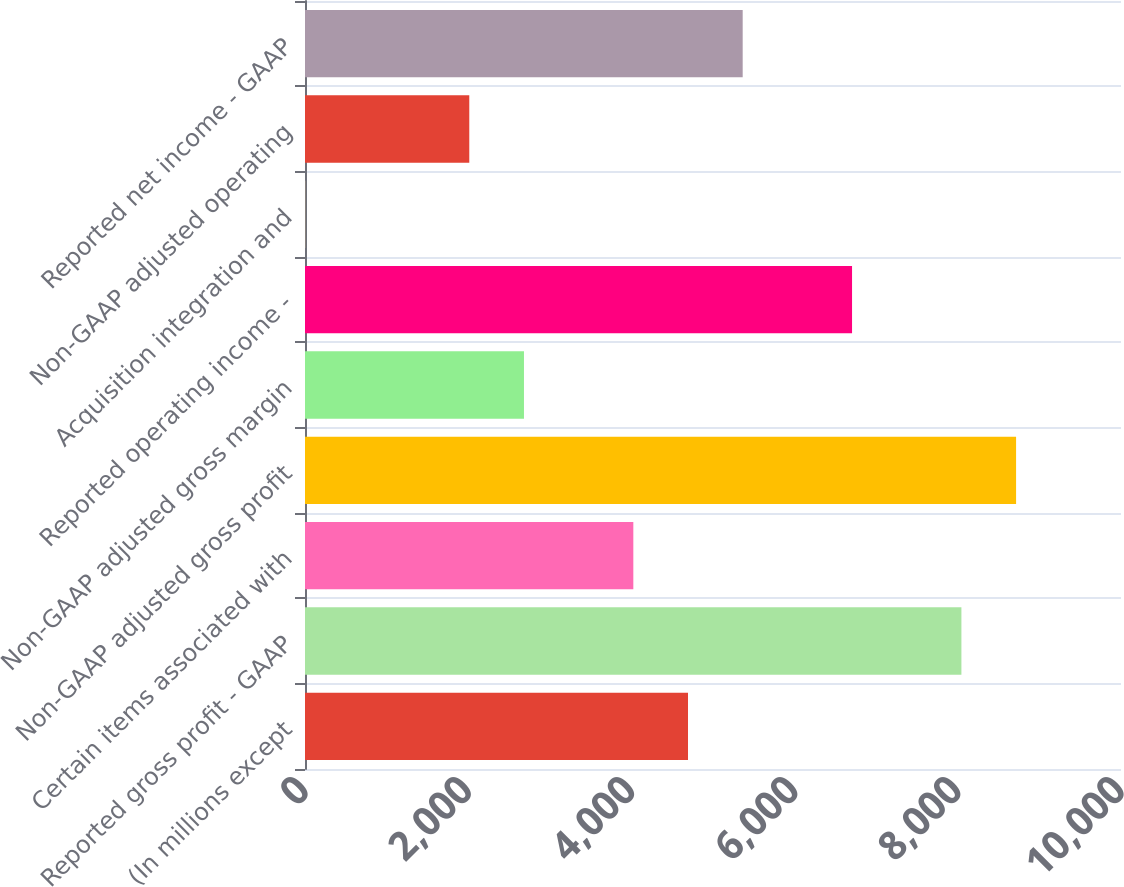<chart> <loc_0><loc_0><loc_500><loc_500><bar_chart><fcel>(In millions except<fcel>Reported gross profit - GAAP<fcel>Certain items associated with<fcel>Non-GAAP adjusted gross profit<fcel>Non-GAAP adjusted gross margin<fcel>Reported operating income -<fcel>Acquisition integration and<fcel>Non-GAAP adjusted operating<fcel>Reported net income - GAAP<nl><fcel>4693.7<fcel>8044.2<fcel>4023.6<fcel>8714.3<fcel>2683.4<fcel>6704<fcel>3<fcel>2013.3<fcel>5363.8<nl></chart> 